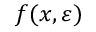<formula> <loc_0><loc_0><loc_500><loc_500>f ( x , \varepsilon )</formula> 